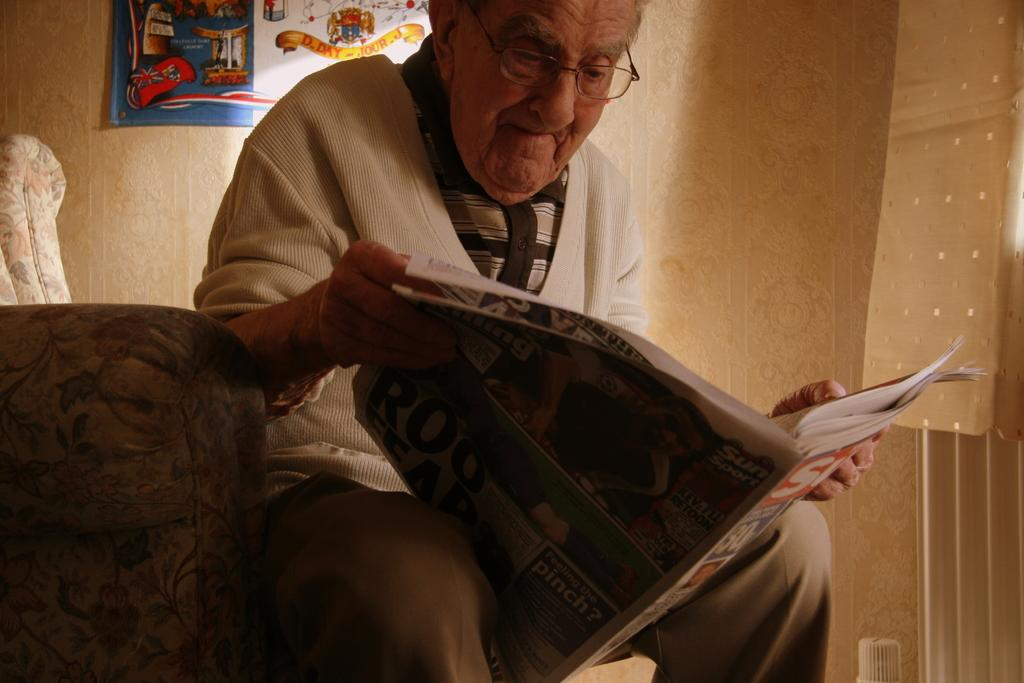What is the man in the image doing? The man is sitting on the couch. What is the man holding in his hands? The man is holding a newspaper in his hands. What can be seen in the background of the image? There are walls visible in the background, and there is an advertisement present. How many legs does the boy have in the image? There is no boy present in the image, so it is not possible to determine the number of legs. 